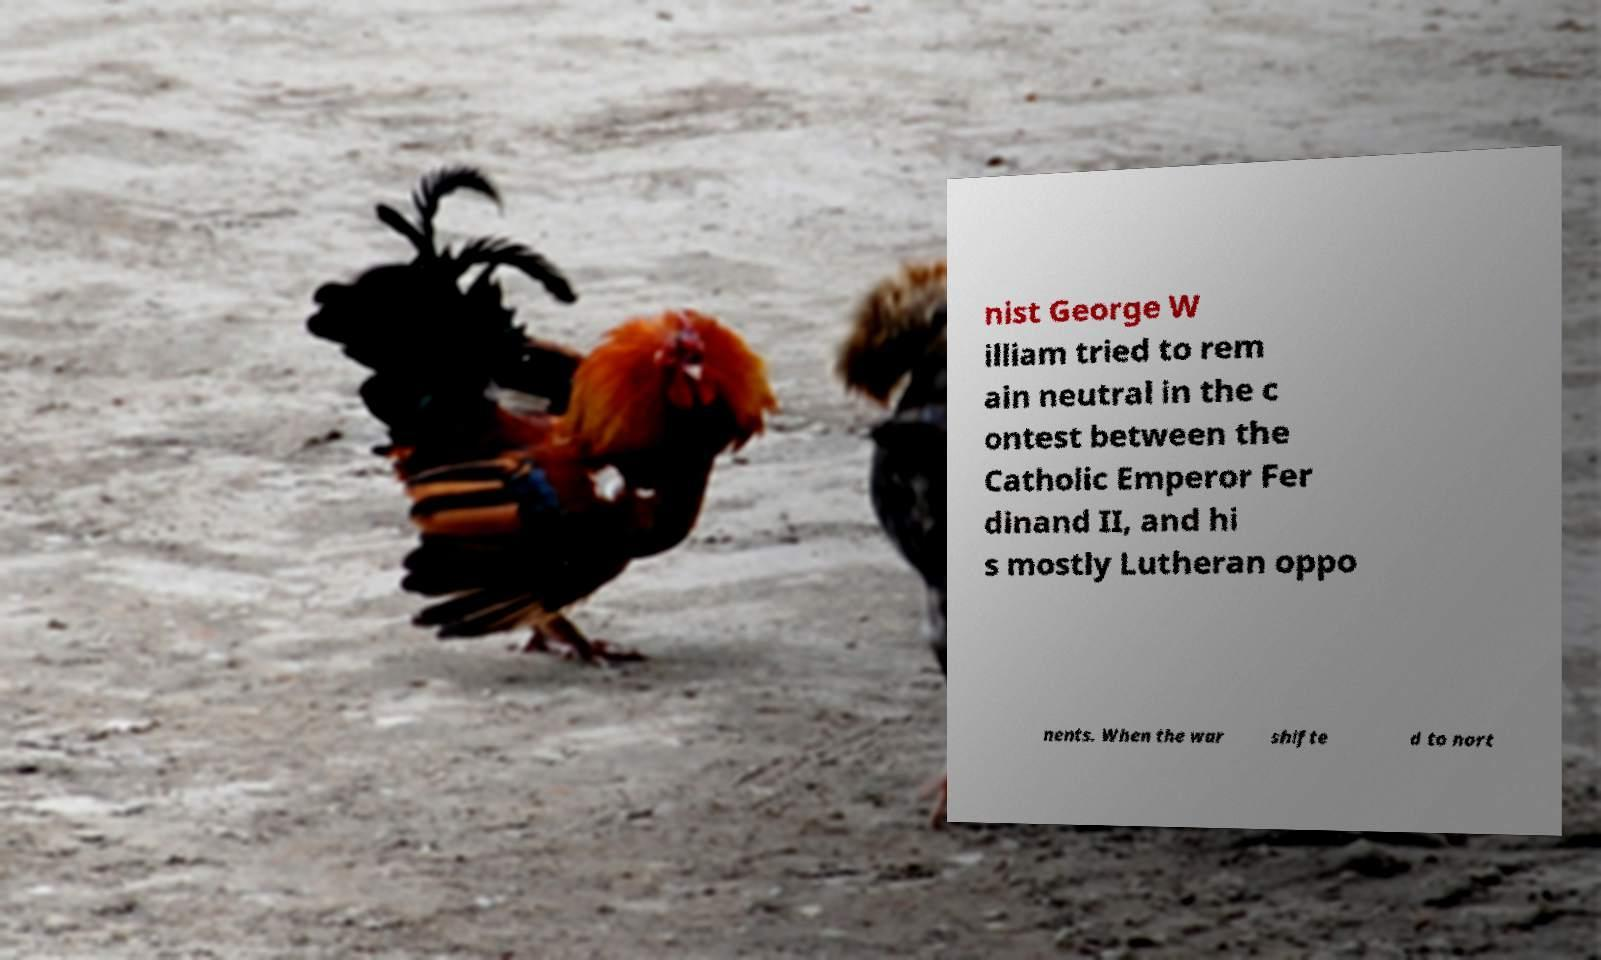There's text embedded in this image that I need extracted. Can you transcribe it verbatim? nist George W illiam tried to rem ain neutral in the c ontest between the Catholic Emperor Fer dinand II, and hi s mostly Lutheran oppo nents. When the war shifte d to nort 